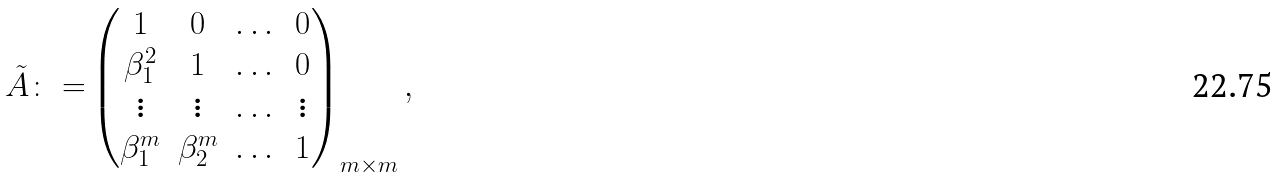Convert formula to latex. <formula><loc_0><loc_0><loc_500><loc_500>\tilde { A } \colon = & \begin{pmatrix} 1 & 0 & \dots & 0 \\ \beta _ { 1 } ^ { 2 } & 1 & \dots & 0 \\ \vdots & \vdots & \dots & \vdots \\ \beta _ { 1 } ^ { m } & \beta _ { 2 } ^ { m } & \dots & 1 \\ \end{pmatrix} _ { m \times m } ,</formula> 